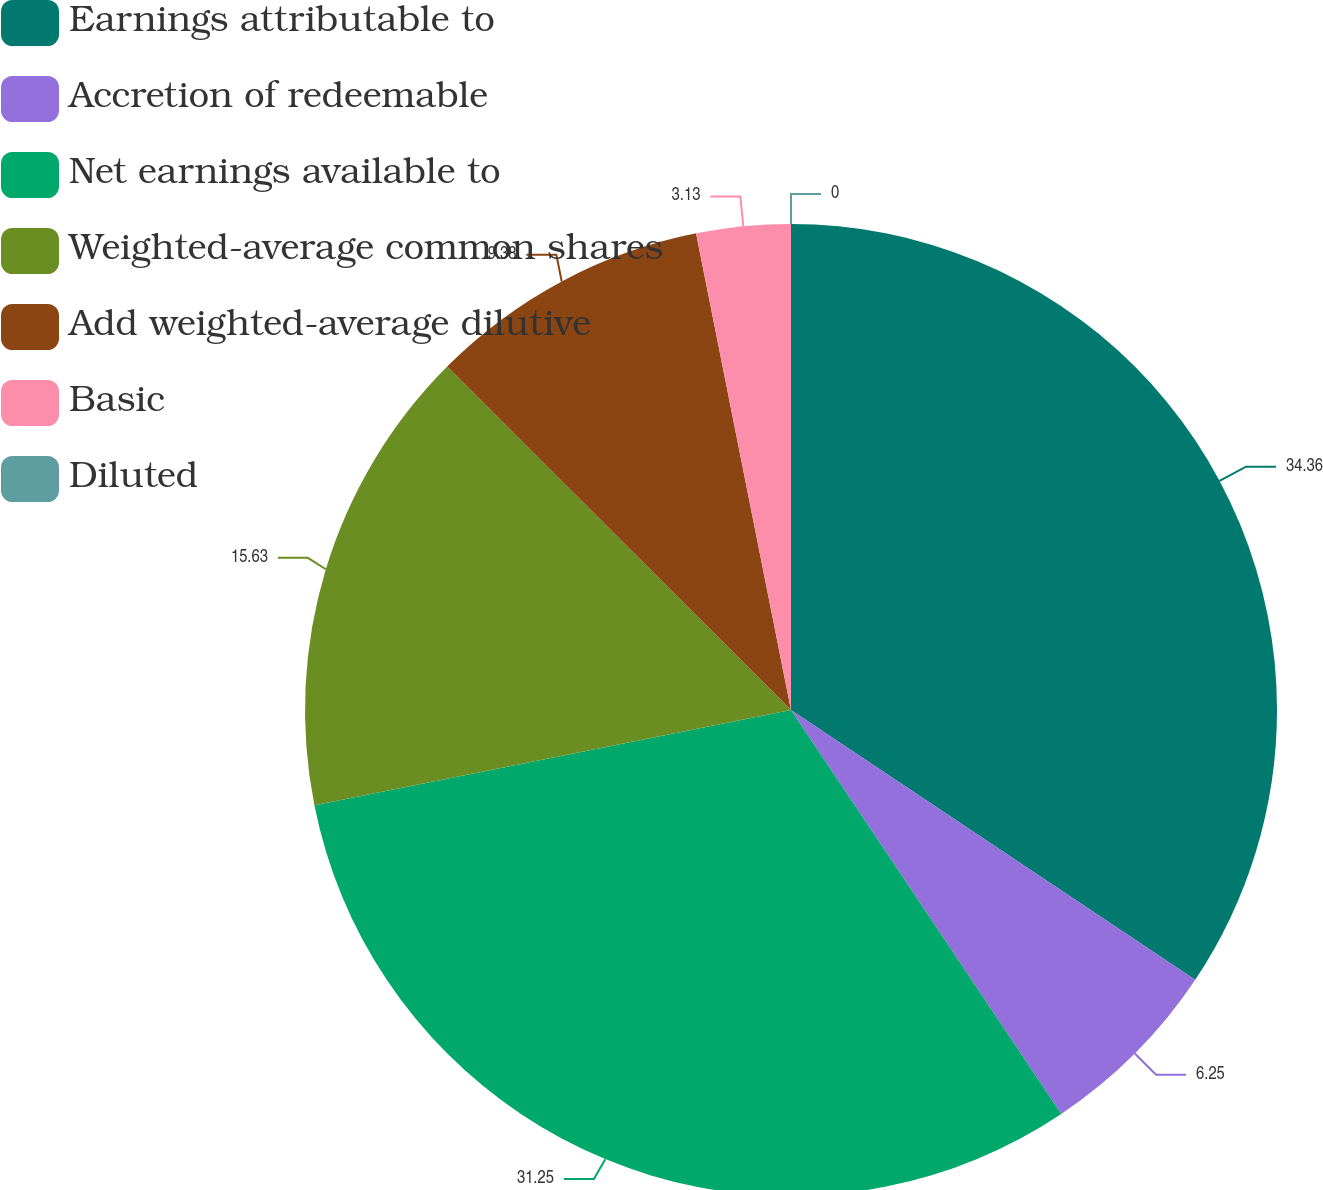Convert chart. <chart><loc_0><loc_0><loc_500><loc_500><pie_chart><fcel>Earnings attributable to<fcel>Accretion of redeemable<fcel>Net earnings available to<fcel>Weighted-average common shares<fcel>Add weighted-average dilutive<fcel>Basic<fcel>Diluted<nl><fcel>34.37%<fcel>6.25%<fcel>31.25%<fcel>15.63%<fcel>9.38%<fcel>3.13%<fcel>0.0%<nl></chart> 